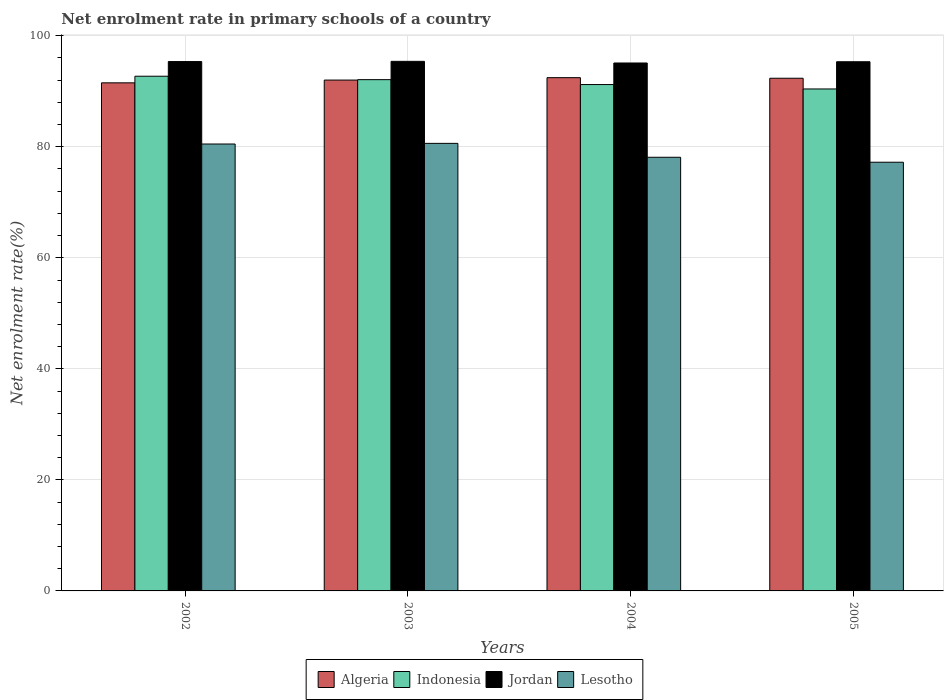Are the number of bars per tick equal to the number of legend labels?
Provide a short and direct response. Yes. How many bars are there on the 3rd tick from the left?
Provide a short and direct response. 4. How many bars are there on the 3rd tick from the right?
Your response must be concise. 4. In how many cases, is the number of bars for a given year not equal to the number of legend labels?
Offer a terse response. 0. What is the net enrolment rate in primary schools in Lesotho in 2002?
Offer a terse response. 80.5. Across all years, what is the maximum net enrolment rate in primary schools in Jordan?
Give a very brief answer. 95.38. Across all years, what is the minimum net enrolment rate in primary schools in Jordan?
Provide a short and direct response. 95.09. What is the total net enrolment rate in primary schools in Lesotho in the graph?
Your answer should be compact. 316.44. What is the difference between the net enrolment rate in primary schools in Lesotho in 2002 and that in 2004?
Offer a very short reply. 2.39. What is the difference between the net enrolment rate in primary schools in Jordan in 2005 and the net enrolment rate in primary schools in Indonesia in 2002?
Ensure brevity in your answer.  2.61. What is the average net enrolment rate in primary schools in Algeria per year?
Your answer should be very brief. 92.08. In the year 2003, what is the difference between the net enrolment rate in primary schools in Indonesia and net enrolment rate in primary schools in Lesotho?
Keep it short and to the point. 11.48. In how many years, is the net enrolment rate in primary schools in Lesotho greater than 68 %?
Offer a very short reply. 4. What is the ratio of the net enrolment rate in primary schools in Jordan in 2003 to that in 2004?
Provide a short and direct response. 1. Is the net enrolment rate in primary schools in Indonesia in 2004 less than that in 2005?
Offer a very short reply. No. Is the difference between the net enrolment rate in primary schools in Indonesia in 2002 and 2005 greater than the difference between the net enrolment rate in primary schools in Lesotho in 2002 and 2005?
Offer a terse response. No. What is the difference between the highest and the second highest net enrolment rate in primary schools in Lesotho?
Ensure brevity in your answer.  0.11. What is the difference between the highest and the lowest net enrolment rate in primary schools in Jordan?
Offer a terse response. 0.29. Is the sum of the net enrolment rate in primary schools in Algeria in 2002 and 2004 greater than the maximum net enrolment rate in primary schools in Jordan across all years?
Keep it short and to the point. Yes. What does the 3rd bar from the left in 2005 represents?
Provide a short and direct response. Jordan. What does the 3rd bar from the right in 2005 represents?
Offer a terse response. Indonesia. Is it the case that in every year, the sum of the net enrolment rate in primary schools in Lesotho and net enrolment rate in primary schools in Algeria is greater than the net enrolment rate in primary schools in Jordan?
Provide a short and direct response. Yes. How many bars are there?
Keep it short and to the point. 16. How many years are there in the graph?
Ensure brevity in your answer.  4. Does the graph contain any zero values?
Offer a terse response. No. Where does the legend appear in the graph?
Your answer should be very brief. Bottom center. How are the legend labels stacked?
Offer a very short reply. Horizontal. What is the title of the graph?
Give a very brief answer. Net enrolment rate in primary schools of a country. What is the label or title of the X-axis?
Offer a very short reply. Years. What is the label or title of the Y-axis?
Keep it short and to the point. Net enrolment rate(%). What is the Net enrolment rate(%) in Algeria in 2002?
Your answer should be compact. 91.52. What is the Net enrolment rate(%) in Indonesia in 2002?
Provide a short and direct response. 92.71. What is the Net enrolment rate(%) of Jordan in 2002?
Provide a short and direct response. 95.35. What is the Net enrolment rate(%) of Lesotho in 2002?
Ensure brevity in your answer.  80.5. What is the Net enrolment rate(%) in Algeria in 2003?
Provide a succinct answer. 92.01. What is the Net enrolment rate(%) in Indonesia in 2003?
Provide a succinct answer. 92.09. What is the Net enrolment rate(%) in Jordan in 2003?
Provide a short and direct response. 95.38. What is the Net enrolment rate(%) of Lesotho in 2003?
Your answer should be very brief. 80.61. What is the Net enrolment rate(%) in Algeria in 2004?
Offer a terse response. 92.45. What is the Net enrolment rate(%) in Indonesia in 2004?
Provide a succinct answer. 91.21. What is the Net enrolment rate(%) in Jordan in 2004?
Offer a very short reply. 95.09. What is the Net enrolment rate(%) of Lesotho in 2004?
Offer a very short reply. 78.11. What is the Net enrolment rate(%) of Algeria in 2005?
Offer a very short reply. 92.34. What is the Net enrolment rate(%) of Indonesia in 2005?
Offer a terse response. 90.41. What is the Net enrolment rate(%) in Jordan in 2005?
Offer a very short reply. 95.32. What is the Net enrolment rate(%) in Lesotho in 2005?
Offer a very short reply. 77.22. Across all years, what is the maximum Net enrolment rate(%) in Algeria?
Give a very brief answer. 92.45. Across all years, what is the maximum Net enrolment rate(%) in Indonesia?
Offer a very short reply. 92.71. Across all years, what is the maximum Net enrolment rate(%) in Jordan?
Offer a very short reply. 95.38. Across all years, what is the maximum Net enrolment rate(%) of Lesotho?
Your answer should be very brief. 80.61. Across all years, what is the minimum Net enrolment rate(%) of Algeria?
Your answer should be very brief. 91.52. Across all years, what is the minimum Net enrolment rate(%) of Indonesia?
Make the answer very short. 90.41. Across all years, what is the minimum Net enrolment rate(%) in Jordan?
Offer a terse response. 95.09. Across all years, what is the minimum Net enrolment rate(%) in Lesotho?
Ensure brevity in your answer.  77.22. What is the total Net enrolment rate(%) in Algeria in the graph?
Provide a short and direct response. 368.32. What is the total Net enrolment rate(%) of Indonesia in the graph?
Keep it short and to the point. 366.41. What is the total Net enrolment rate(%) of Jordan in the graph?
Your answer should be compact. 381.14. What is the total Net enrolment rate(%) in Lesotho in the graph?
Provide a succinct answer. 316.44. What is the difference between the Net enrolment rate(%) of Algeria in 2002 and that in 2003?
Provide a short and direct response. -0.5. What is the difference between the Net enrolment rate(%) of Indonesia in 2002 and that in 2003?
Ensure brevity in your answer.  0.62. What is the difference between the Net enrolment rate(%) in Jordan in 2002 and that in 2003?
Make the answer very short. -0.04. What is the difference between the Net enrolment rate(%) of Lesotho in 2002 and that in 2003?
Your answer should be compact. -0.11. What is the difference between the Net enrolment rate(%) in Algeria in 2002 and that in 2004?
Provide a succinct answer. -0.93. What is the difference between the Net enrolment rate(%) of Indonesia in 2002 and that in 2004?
Give a very brief answer. 1.5. What is the difference between the Net enrolment rate(%) of Jordan in 2002 and that in 2004?
Keep it short and to the point. 0.26. What is the difference between the Net enrolment rate(%) of Lesotho in 2002 and that in 2004?
Keep it short and to the point. 2.39. What is the difference between the Net enrolment rate(%) in Algeria in 2002 and that in 2005?
Offer a terse response. -0.83. What is the difference between the Net enrolment rate(%) in Indonesia in 2002 and that in 2005?
Provide a succinct answer. 2.3. What is the difference between the Net enrolment rate(%) of Jordan in 2002 and that in 2005?
Provide a succinct answer. 0.03. What is the difference between the Net enrolment rate(%) of Lesotho in 2002 and that in 2005?
Keep it short and to the point. 3.28. What is the difference between the Net enrolment rate(%) in Algeria in 2003 and that in 2004?
Your answer should be compact. -0.44. What is the difference between the Net enrolment rate(%) of Indonesia in 2003 and that in 2004?
Your response must be concise. 0.88. What is the difference between the Net enrolment rate(%) in Jordan in 2003 and that in 2004?
Ensure brevity in your answer.  0.29. What is the difference between the Net enrolment rate(%) of Lesotho in 2003 and that in 2004?
Provide a succinct answer. 2.5. What is the difference between the Net enrolment rate(%) in Algeria in 2003 and that in 2005?
Your response must be concise. -0.33. What is the difference between the Net enrolment rate(%) of Indonesia in 2003 and that in 2005?
Your answer should be compact. 1.68. What is the difference between the Net enrolment rate(%) of Jordan in 2003 and that in 2005?
Your response must be concise. 0.07. What is the difference between the Net enrolment rate(%) in Lesotho in 2003 and that in 2005?
Your answer should be compact. 3.4. What is the difference between the Net enrolment rate(%) of Algeria in 2004 and that in 2005?
Provide a short and direct response. 0.11. What is the difference between the Net enrolment rate(%) of Indonesia in 2004 and that in 2005?
Make the answer very short. 0.8. What is the difference between the Net enrolment rate(%) of Jordan in 2004 and that in 2005?
Offer a very short reply. -0.22. What is the difference between the Net enrolment rate(%) in Lesotho in 2004 and that in 2005?
Provide a short and direct response. 0.89. What is the difference between the Net enrolment rate(%) of Algeria in 2002 and the Net enrolment rate(%) of Indonesia in 2003?
Offer a terse response. -0.57. What is the difference between the Net enrolment rate(%) in Algeria in 2002 and the Net enrolment rate(%) in Jordan in 2003?
Provide a succinct answer. -3.87. What is the difference between the Net enrolment rate(%) in Algeria in 2002 and the Net enrolment rate(%) in Lesotho in 2003?
Make the answer very short. 10.9. What is the difference between the Net enrolment rate(%) in Indonesia in 2002 and the Net enrolment rate(%) in Jordan in 2003?
Offer a very short reply. -2.68. What is the difference between the Net enrolment rate(%) of Indonesia in 2002 and the Net enrolment rate(%) of Lesotho in 2003?
Give a very brief answer. 12.09. What is the difference between the Net enrolment rate(%) in Jordan in 2002 and the Net enrolment rate(%) in Lesotho in 2003?
Offer a terse response. 14.73. What is the difference between the Net enrolment rate(%) in Algeria in 2002 and the Net enrolment rate(%) in Indonesia in 2004?
Your answer should be very brief. 0.31. What is the difference between the Net enrolment rate(%) in Algeria in 2002 and the Net enrolment rate(%) in Jordan in 2004?
Provide a short and direct response. -3.58. What is the difference between the Net enrolment rate(%) of Algeria in 2002 and the Net enrolment rate(%) of Lesotho in 2004?
Provide a short and direct response. 13.41. What is the difference between the Net enrolment rate(%) of Indonesia in 2002 and the Net enrolment rate(%) of Jordan in 2004?
Your answer should be very brief. -2.38. What is the difference between the Net enrolment rate(%) in Indonesia in 2002 and the Net enrolment rate(%) in Lesotho in 2004?
Your answer should be very brief. 14.6. What is the difference between the Net enrolment rate(%) in Jordan in 2002 and the Net enrolment rate(%) in Lesotho in 2004?
Your answer should be very brief. 17.24. What is the difference between the Net enrolment rate(%) in Algeria in 2002 and the Net enrolment rate(%) in Indonesia in 2005?
Keep it short and to the point. 1.1. What is the difference between the Net enrolment rate(%) of Algeria in 2002 and the Net enrolment rate(%) of Jordan in 2005?
Your response must be concise. -3.8. What is the difference between the Net enrolment rate(%) of Algeria in 2002 and the Net enrolment rate(%) of Lesotho in 2005?
Give a very brief answer. 14.3. What is the difference between the Net enrolment rate(%) of Indonesia in 2002 and the Net enrolment rate(%) of Jordan in 2005?
Ensure brevity in your answer.  -2.61. What is the difference between the Net enrolment rate(%) in Indonesia in 2002 and the Net enrolment rate(%) in Lesotho in 2005?
Provide a short and direct response. 15.49. What is the difference between the Net enrolment rate(%) of Jordan in 2002 and the Net enrolment rate(%) of Lesotho in 2005?
Keep it short and to the point. 18.13. What is the difference between the Net enrolment rate(%) in Algeria in 2003 and the Net enrolment rate(%) in Indonesia in 2004?
Make the answer very short. 0.81. What is the difference between the Net enrolment rate(%) in Algeria in 2003 and the Net enrolment rate(%) in Jordan in 2004?
Make the answer very short. -3.08. What is the difference between the Net enrolment rate(%) in Algeria in 2003 and the Net enrolment rate(%) in Lesotho in 2004?
Your answer should be very brief. 13.9. What is the difference between the Net enrolment rate(%) of Indonesia in 2003 and the Net enrolment rate(%) of Jordan in 2004?
Give a very brief answer. -3. What is the difference between the Net enrolment rate(%) in Indonesia in 2003 and the Net enrolment rate(%) in Lesotho in 2004?
Offer a very short reply. 13.98. What is the difference between the Net enrolment rate(%) of Jordan in 2003 and the Net enrolment rate(%) of Lesotho in 2004?
Provide a succinct answer. 17.28. What is the difference between the Net enrolment rate(%) in Algeria in 2003 and the Net enrolment rate(%) in Indonesia in 2005?
Make the answer very short. 1.6. What is the difference between the Net enrolment rate(%) of Algeria in 2003 and the Net enrolment rate(%) of Jordan in 2005?
Your answer should be compact. -3.3. What is the difference between the Net enrolment rate(%) in Algeria in 2003 and the Net enrolment rate(%) in Lesotho in 2005?
Give a very brief answer. 14.8. What is the difference between the Net enrolment rate(%) in Indonesia in 2003 and the Net enrolment rate(%) in Jordan in 2005?
Your response must be concise. -3.23. What is the difference between the Net enrolment rate(%) in Indonesia in 2003 and the Net enrolment rate(%) in Lesotho in 2005?
Offer a very short reply. 14.87. What is the difference between the Net enrolment rate(%) in Jordan in 2003 and the Net enrolment rate(%) in Lesotho in 2005?
Keep it short and to the point. 18.17. What is the difference between the Net enrolment rate(%) in Algeria in 2004 and the Net enrolment rate(%) in Indonesia in 2005?
Give a very brief answer. 2.04. What is the difference between the Net enrolment rate(%) in Algeria in 2004 and the Net enrolment rate(%) in Jordan in 2005?
Your response must be concise. -2.87. What is the difference between the Net enrolment rate(%) in Algeria in 2004 and the Net enrolment rate(%) in Lesotho in 2005?
Keep it short and to the point. 15.23. What is the difference between the Net enrolment rate(%) of Indonesia in 2004 and the Net enrolment rate(%) of Jordan in 2005?
Offer a very short reply. -4.11. What is the difference between the Net enrolment rate(%) of Indonesia in 2004 and the Net enrolment rate(%) of Lesotho in 2005?
Your response must be concise. 13.99. What is the difference between the Net enrolment rate(%) of Jordan in 2004 and the Net enrolment rate(%) of Lesotho in 2005?
Ensure brevity in your answer.  17.87. What is the average Net enrolment rate(%) of Algeria per year?
Make the answer very short. 92.08. What is the average Net enrolment rate(%) in Indonesia per year?
Keep it short and to the point. 91.6. What is the average Net enrolment rate(%) in Jordan per year?
Your answer should be very brief. 95.28. What is the average Net enrolment rate(%) in Lesotho per year?
Keep it short and to the point. 79.11. In the year 2002, what is the difference between the Net enrolment rate(%) in Algeria and Net enrolment rate(%) in Indonesia?
Provide a succinct answer. -1.19. In the year 2002, what is the difference between the Net enrolment rate(%) of Algeria and Net enrolment rate(%) of Jordan?
Ensure brevity in your answer.  -3.83. In the year 2002, what is the difference between the Net enrolment rate(%) in Algeria and Net enrolment rate(%) in Lesotho?
Keep it short and to the point. 11.02. In the year 2002, what is the difference between the Net enrolment rate(%) in Indonesia and Net enrolment rate(%) in Jordan?
Give a very brief answer. -2.64. In the year 2002, what is the difference between the Net enrolment rate(%) of Indonesia and Net enrolment rate(%) of Lesotho?
Keep it short and to the point. 12.21. In the year 2002, what is the difference between the Net enrolment rate(%) in Jordan and Net enrolment rate(%) in Lesotho?
Keep it short and to the point. 14.85. In the year 2003, what is the difference between the Net enrolment rate(%) in Algeria and Net enrolment rate(%) in Indonesia?
Provide a succinct answer. -0.08. In the year 2003, what is the difference between the Net enrolment rate(%) of Algeria and Net enrolment rate(%) of Jordan?
Offer a terse response. -3.37. In the year 2003, what is the difference between the Net enrolment rate(%) of Algeria and Net enrolment rate(%) of Lesotho?
Offer a very short reply. 11.4. In the year 2003, what is the difference between the Net enrolment rate(%) of Indonesia and Net enrolment rate(%) of Jordan?
Provide a short and direct response. -3.3. In the year 2003, what is the difference between the Net enrolment rate(%) of Indonesia and Net enrolment rate(%) of Lesotho?
Keep it short and to the point. 11.48. In the year 2003, what is the difference between the Net enrolment rate(%) of Jordan and Net enrolment rate(%) of Lesotho?
Provide a succinct answer. 14.77. In the year 2004, what is the difference between the Net enrolment rate(%) in Algeria and Net enrolment rate(%) in Indonesia?
Keep it short and to the point. 1.24. In the year 2004, what is the difference between the Net enrolment rate(%) of Algeria and Net enrolment rate(%) of Jordan?
Offer a very short reply. -2.64. In the year 2004, what is the difference between the Net enrolment rate(%) of Algeria and Net enrolment rate(%) of Lesotho?
Your answer should be very brief. 14.34. In the year 2004, what is the difference between the Net enrolment rate(%) of Indonesia and Net enrolment rate(%) of Jordan?
Your answer should be very brief. -3.88. In the year 2004, what is the difference between the Net enrolment rate(%) in Indonesia and Net enrolment rate(%) in Lesotho?
Make the answer very short. 13.1. In the year 2004, what is the difference between the Net enrolment rate(%) in Jordan and Net enrolment rate(%) in Lesotho?
Provide a short and direct response. 16.98. In the year 2005, what is the difference between the Net enrolment rate(%) in Algeria and Net enrolment rate(%) in Indonesia?
Give a very brief answer. 1.93. In the year 2005, what is the difference between the Net enrolment rate(%) in Algeria and Net enrolment rate(%) in Jordan?
Your response must be concise. -2.97. In the year 2005, what is the difference between the Net enrolment rate(%) of Algeria and Net enrolment rate(%) of Lesotho?
Your answer should be compact. 15.12. In the year 2005, what is the difference between the Net enrolment rate(%) of Indonesia and Net enrolment rate(%) of Jordan?
Your response must be concise. -4.9. In the year 2005, what is the difference between the Net enrolment rate(%) of Indonesia and Net enrolment rate(%) of Lesotho?
Give a very brief answer. 13.19. In the year 2005, what is the difference between the Net enrolment rate(%) in Jordan and Net enrolment rate(%) in Lesotho?
Make the answer very short. 18.1. What is the ratio of the Net enrolment rate(%) in Algeria in 2002 to that in 2003?
Keep it short and to the point. 0.99. What is the ratio of the Net enrolment rate(%) in Lesotho in 2002 to that in 2003?
Your answer should be very brief. 1. What is the ratio of the Net enrolment rate(%) of Indonesia in 2002 to that in 2004?
Provide a short and direct response. 1.02. What is the ratio of the Net enrolment rate(%) in Lesotho in 2002 to that in 2004?
Your response must be concise. 1.03. What is the ratio of the Net enrolment rate(%) of Algeria in 2002 to that in 2005?
Your answer should be very brief. 0.99. What is the ratio of the Net enrolment rate(%) of Indonesia in 2002 to that in 2005?
Offer a terse response. 1.03. What is the ratio of the Net enrolment rate(%) of Lesotho in 2002 to that in 2005?
Your answer should be very brief. 1.04. What is the ratio of the Net enrolment rate(%) in Indonesia in 2003 to that in 2004?
Your answer should be very brief. 1.01. What is the ratio of the Net enrolment rate(%) of Lesotho in 2003 to that in 2004?
Your answer should be very brief. 1.03. What is the ratio of the Net enrolment rate(%) of Indonesia in 2003 to that in 2005?
Offer a terse response. 1.02. What is the ratio of the Net enrolment rate(%) in Jordan in 2003 to that in 2005?
Your answer should be compact. 1. What is the ratio of the Net enrolment rate(%) of Lesotho in 2003 to that in 2005?
Ensure brevity in your answer.  1.04. What is the ratio of the Net enrolment rate(%) in Algeria in 2004 to that in 2005?
Offer a very short reply. 1. What is the ratio of the Net enrolment rate(%) of Indonesia in 2004 to that in 2005?
Offer a terse response. 1.01. What is the ratio of the Net enrolment rate(%) in Jordan in 2004 to that in 2005?
Keep it short and to the point. 1. What is the ratio of the Net enrolment rate(%) in Lesotho in 2004 to that in 2005?
Provide a short and direct response. 1.01. What is the difference between the highest and the second highest Net enrolment rate(%) of Algeria?
Give a very brief answer. 0.11. What is the difference between the highest and the second highest Net enrolment rate(%) of Indonesia?
Offer a terse response. 0.62. What is the difference between the highest and the second highest Net enrolment rate(%) in Jordan?
Keep it short and to the point. 0.04. What is the difference between the highest and the second highest Net enrolment rate(%) of Lesotho?
Offer a terse response. 0.11. What is the difference between the highest and the lowest Net enrolment rate(%) of Algeria?
Ensure brevity in your answer.  0.93. What is the difference between the highest and the lowest Net enrolment rate(%) in Indonesia?
Your answer should be compact. 2.3. What is the difference between the highest and the lowest Net enrolment rate(%) in Jordan?
Your answer should be compact. 0.29. What is the difference between the highest and the lowest Net enrolment rate(%) of Lesotho?
Offer a very short reply. 3.4. 